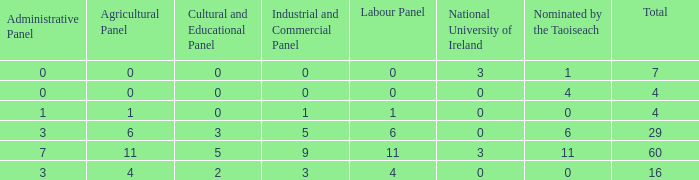What is the average nominated of the composition nominated by Taioseach with an Industrial and Commercial panel less than 9, an administrative panel greater than 0, a cultural and educational panel greater than 2, and a total less than 29? None. 